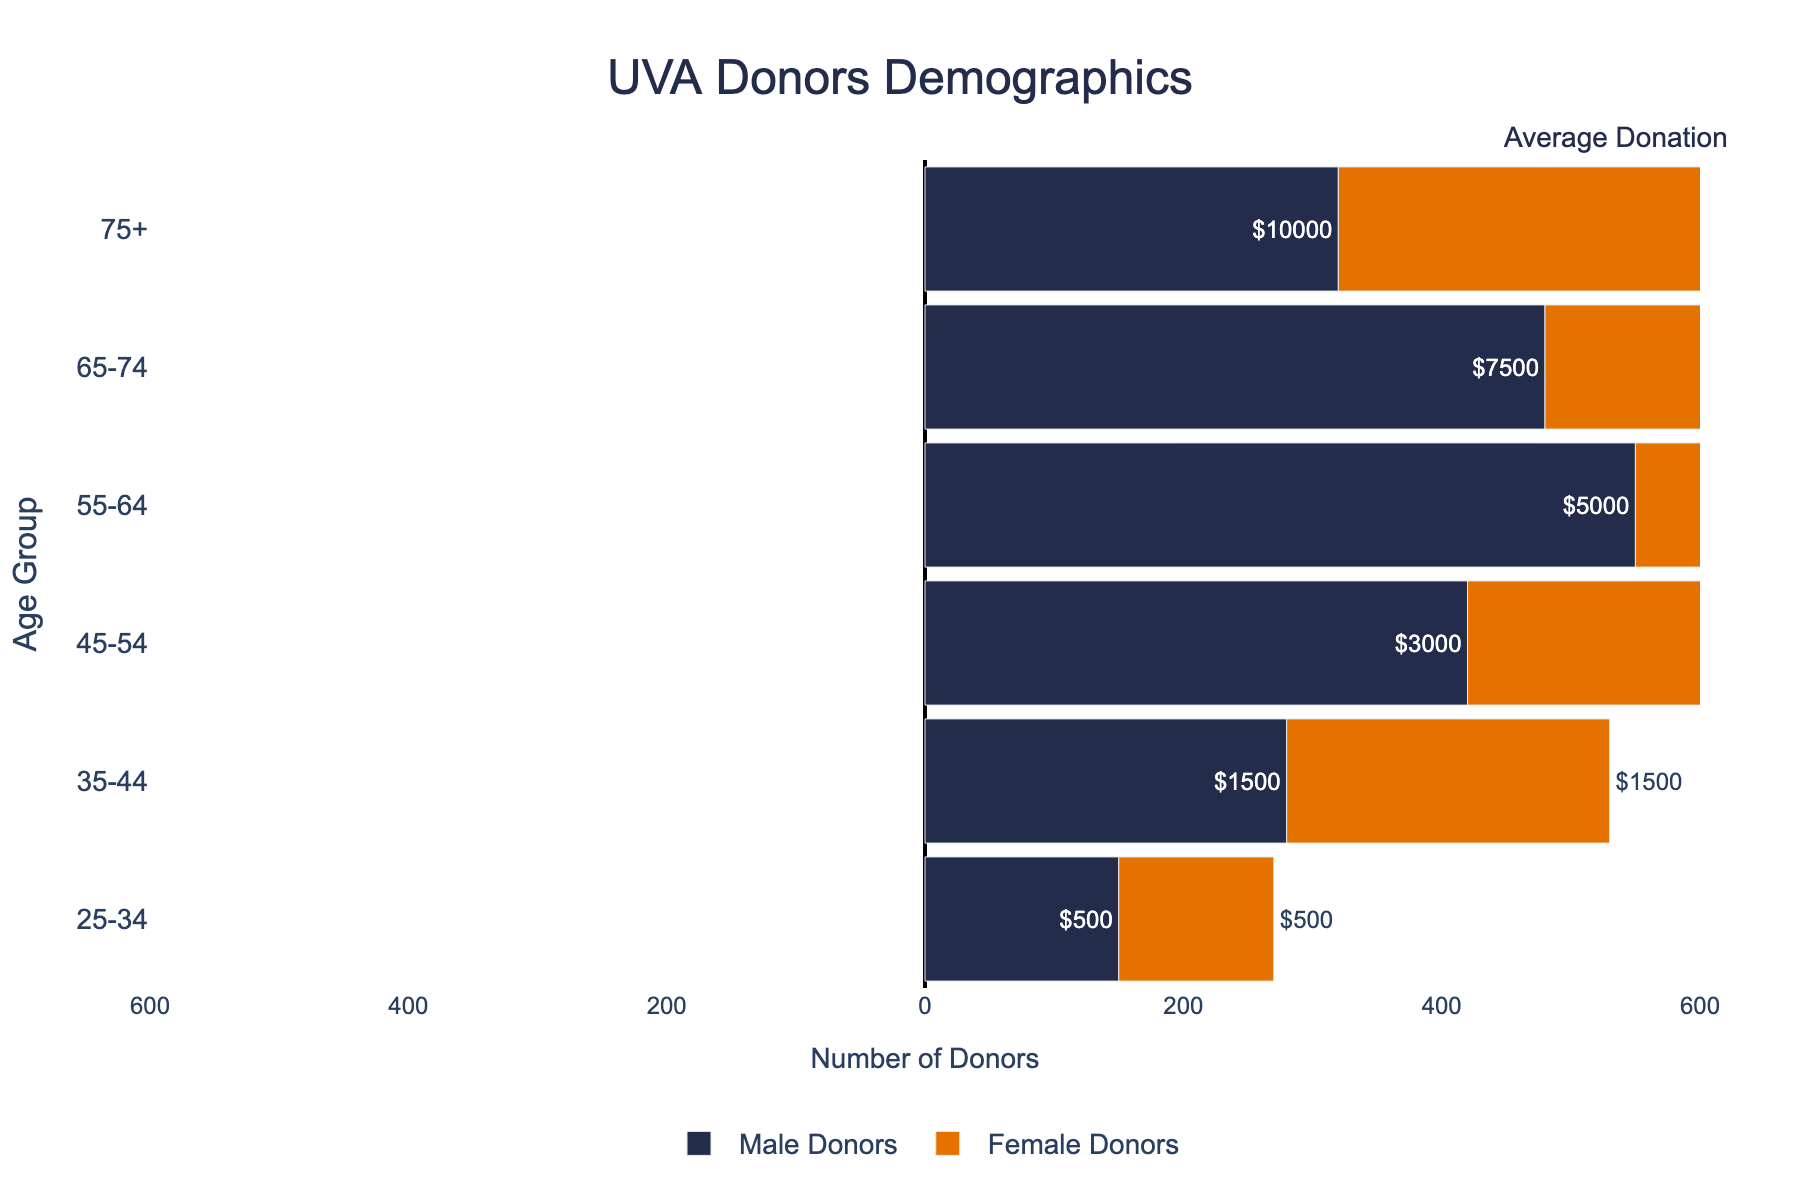What's the title of the figure? The title is located at the top center of the figure. It reads "UVA Donors Demographics," which indicates that the figure shows demographic data for UVA donors.
Answer: UVA Donors Demographics What are the age groups represented in the figure? The age groups are displayed along the y-axis of the figure. They include the following categories: 25-34, 35-44, 45-54, 55-64, 65-74, and 75+.
Answer: 25-34, 35-44, 45-54, 55-64, 65-74, 75+ Which age group has the highest number of male donors? By looking at the horizontal bars for male donors, the longest bar represents the age group with the highest number of male donors. The 55-64 age group has the longest bar for male donors, indicating 550 male donors.
Answer: 55-64 What's the total number of female donors in the 45-54 age group? The length of the bar corresponding to female donors in the 45-54 age group is 390, as indicated by the negative value on the x-axis. Thus, there are 390 female donors in this age group.
Answer: 390 How does the average donation amount change with increasing age groups? Average donation amounts for each age group are displayed on the figure’s tooltip. Examining each tooltip, we see the following amounts: $500 (25-34), $1500 (35-44), $3000 (45-54), $5000 (55-64), $7500 (65-74), and $10000 (75+). The average donation amount increases with each successive age group.
Answer: Increases Compare the number of male donors and female donors in the 35-44 age group. The number of male donors in the 35-44 age group is 280, while the number of female donors is 250, as indicated by the lengths of their respective bars. The male donors outnumber the female donors.
Answer: 280 vs. 250 Which age group has the highest average donation? Observing the average donation amounts for each age group, the 75+ age group has the highest average donation amount, which is $10000.
Answer: 75+ What is the combined number of donors in the 65-74 age group? To find the combined number of donors, add the number of male and female donors in the 65-74 age group. The figure shows 480 male donors and 450 female donors, so the total is 480 + 450 = 930.
Answer: 930 In which age group do male donors outnumber female donors the most? To determine this, check the difference in the number of donors for each age group. For the 55-64 age group, the difference is largest: 550 male donors - 510 female donors = 40. This is the largest difference compared to other age groups.
Answer: 55-64 How many more donors are there in the 45-54 age group compared to the 35-44 age group? Calculate the total number of donors for each age group and then find the difference. For 45-54: 420 (males) + 390 (females) = 810. For 35-44: 280 (males) + 250 (females) = 530. So the difference is 810 - 530 = 280.
Answer: 280 